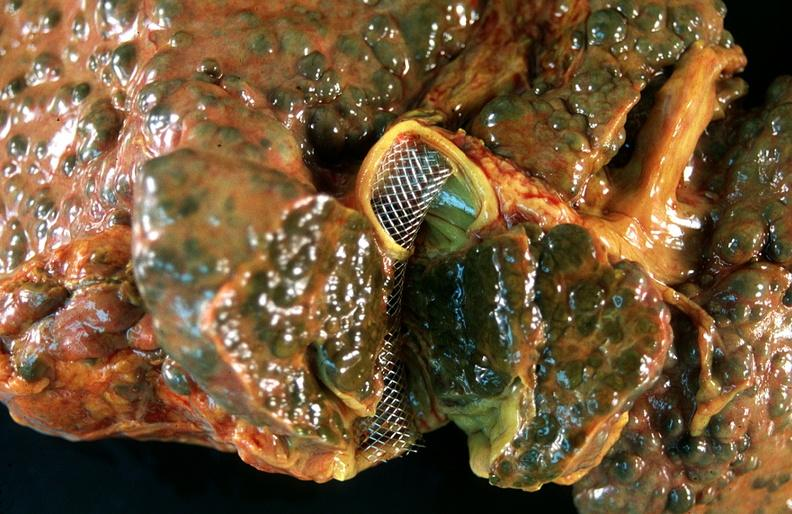what does this image show?
Answer the question using a single word or phrase. Liver 